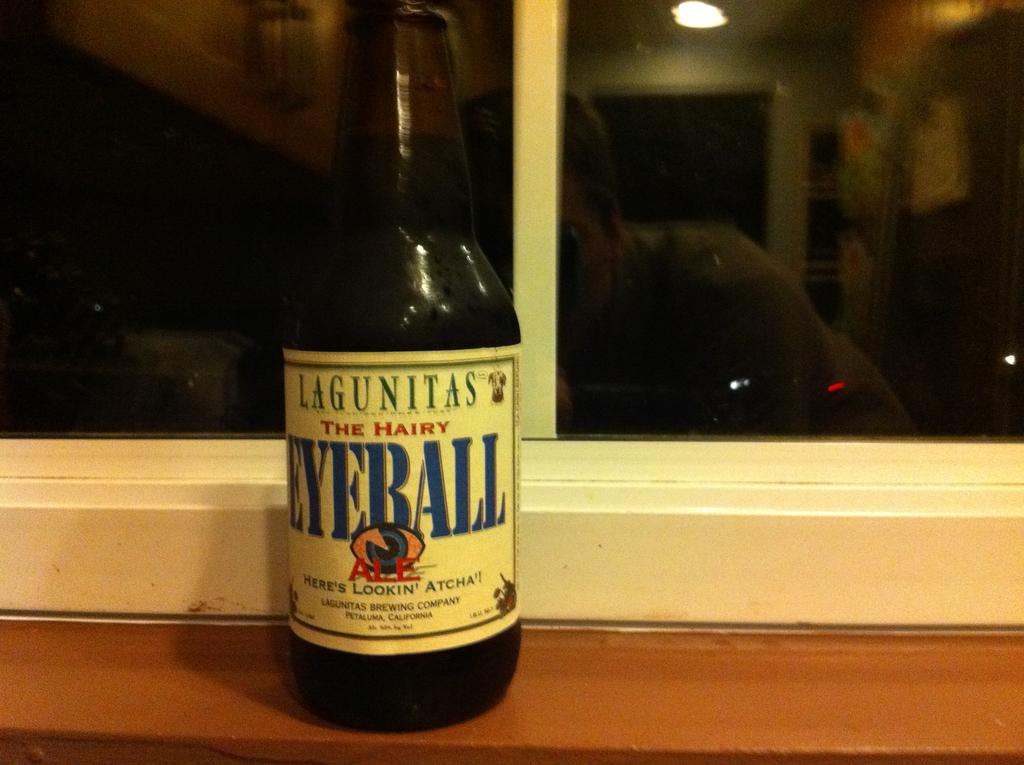What brand made this beverage?
Offer a very short reply. Lagunitas. What kind of eyeball is mentioned on the bottle?
Offer a terse response. Hairy. 